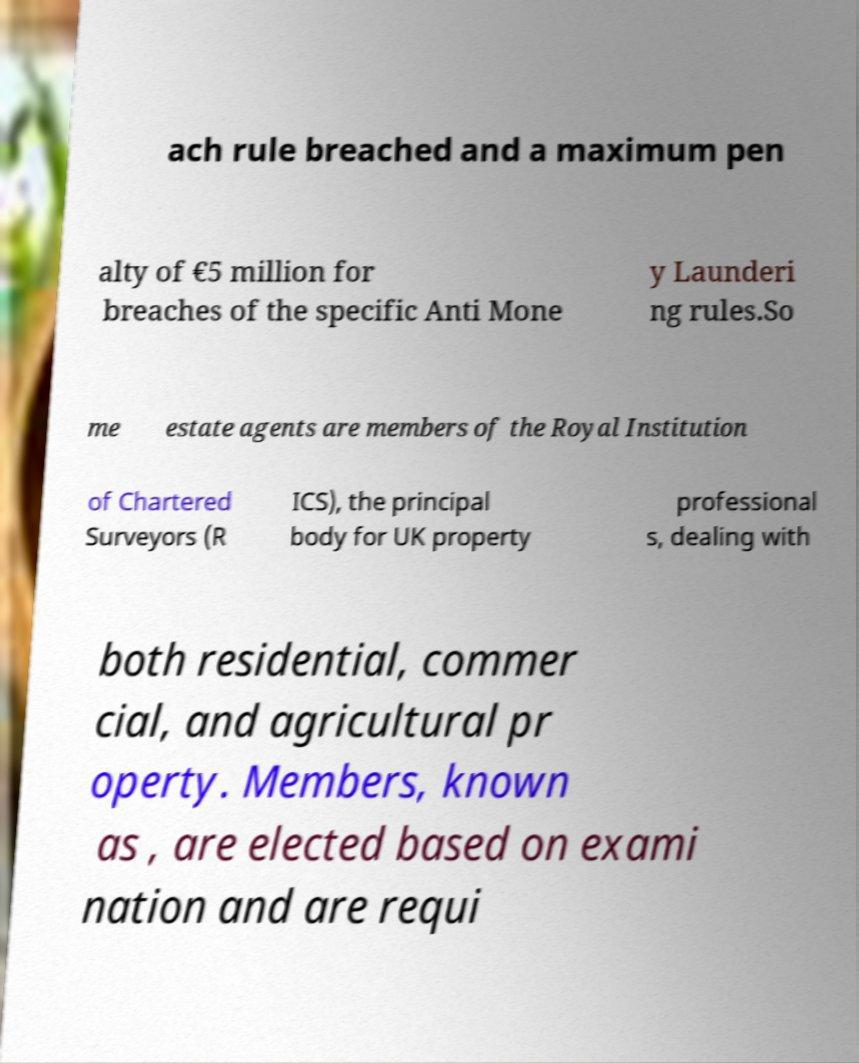Could you extract and type out the text from this image? ach rule breached and a maximum pen alty of €5 million for breaches of the specific Anti Mone y Launderi ng rules.So me estate agents are members of the Royal Institution of Chartered Surveyors (R ICS), the principal body for UK property professional s, dealing with both residential, commer cial, and agricultural pr operty. Members, known as , are elected based on exami nation and are requi 